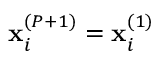<formula> <loc_0><loc_0><loc_500><loc_500>x _ { i } ^ { ( P + 1 ) } = x _ { i } ^ { ( 1 ) }</formula> 